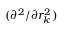<formula> <loc_0><loc_0><loc_500><loc_500>( \partial ^ { 2 } / \partial r _ { k } ^ { 2 } )</formula> 